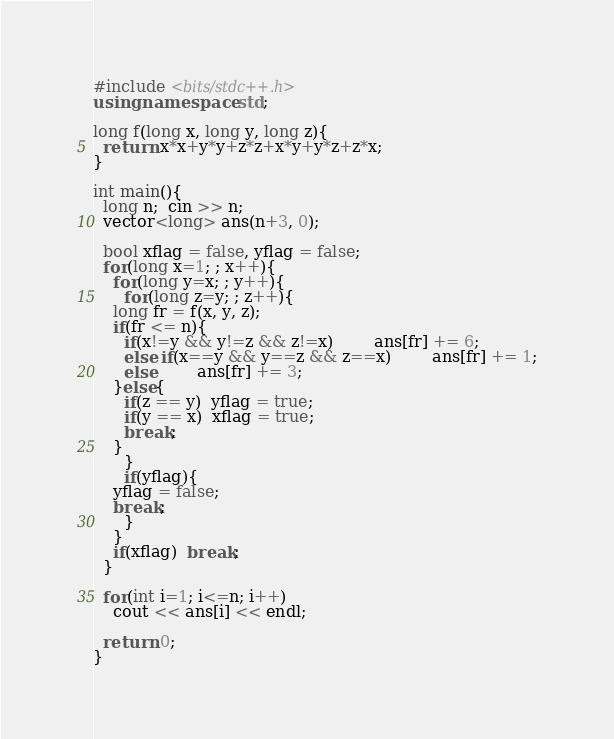<code> <loc_0><loc_0><loc_500><loc_500><_C++_>#include <bits/stdc++.h>
using namespace std;

long f(long x, long y, long z){
  return x*x+y*y+z*z+x*y+y*z+z*x;
}

int main(){
  long n;  cin >> n;
  vector<long> ans(n+3, 0);

  bool xflag = false, yflag = false;
  for(long x=1; ; x++){
    for(long y=x; ; y++){
      for(long z=y; ; z++){
	long fr = f(x, y, z);
	if(fr <= n){
	  if(x!=y && y!=z && z!=x)	    ans[fr] += 6;
	  else if(x==y && y==z && z==x)	    ans[fr] += 1;
	  else	    ans[fr] += 3;
	}else{
	  if(z == y)  yflag = true;
	  if(y == x)  xflag = true;
	  break;
	}
      }
      if(yflag){
	yflag = false;
	break;
      }
    }
    if(xflag)  break;
  }

  for(int i=1; i<=n; i++)
    cout << ans[i] << endl;

  return 0;
}
</code> 